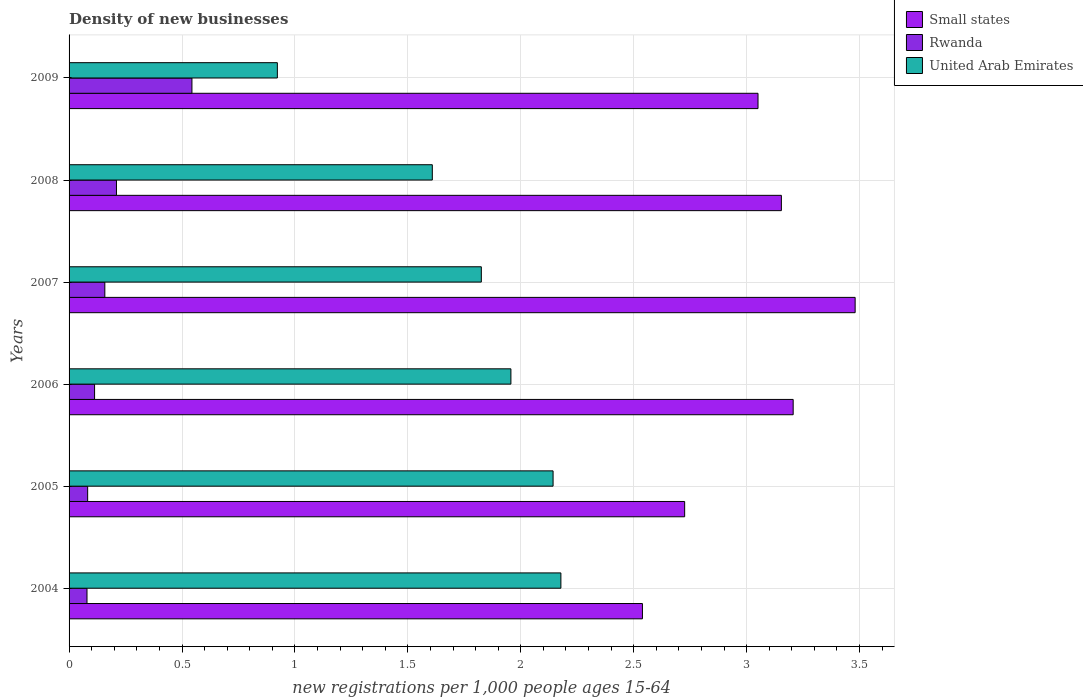Are the number of bars per tick equal to the number of legend labels?
Keep it short and to the point. Yes. How many bars are there on the 3rd tick from the bottom?
Your response must be concise. 3. What is the label of the 2nd group of bars from the top?
Give a very brief answer. 2008. In how many cases, is the number of bars for a given year not equal to the number of legend labels?
Provide a short and direct response. 0. What is the number of new registrations in United Arab Emirates in 2006?
Provide a succinct answer. 1.96. Across all years, what is the maximum number of new registrations in United Arab Emirates?
Your response must be concise. 2.18. Across all years, what is the minimum number of new registrations in Rwanda?
Ensure brevity in your answer.  0.08. In which year was the number of new registrations in United Arab Emirates maximum?
Offer a terse response. 2004. In which year was the number of new registrations in United Arab Emirates minimum?
Provide a succinct answer. 2009. What is the total number of new registrations in Rwanda in the graph?
Your answer should be very brief. 1.19. What is the difference between the number of new registrations in Small states in 2004 and that in 2005?
Provide a succinct answer. -0.19. What is the difference between the number of new registrations in Rwanda in 2004 and the number of new registrations in United Arab Emirates in 2009?
Give a very brief answer. -0.84. What is the average number of new registrations in Small states per year?
Make the answer very short. 3.03. In the year 2009, what is the difference between the number of new registrations in Small states and number of new registrations in Rwanda?
Offer a very short reply. 2.51. What is the ratio of the number of new registrations in United Arab Emirates in 2007 to that in 2008?
Keep it short and to the point. 1.13. Is the difference between the number of new registrations in Small states in 2004 and 2007 greater than the difference between the number of new registrations in Rwanda in 2004 and 2007?
Offer a terse response. No. What is the difference between the highest and the second highest number of new registrations in United Arab Emirates?
Make the answer very short. 0.03. What is the difference between the highest and the lowest number of new registrations in Small states?
Your answer should be compact. 0.94. In how many years, is the number of new registrations in Small states greater than the average number of new registrations in Small states taken over all years?
Make the answer very short. 4. Is the sum of the number of new registrations in United Arab Emirates in 2004 and 2005 greater than the maximum number of new registrations in Small states across all years?
Provide a short and direct response. Yes. What does the 1st bar from the top in 2007 represents?
Make the answer very short. United Arab Emirates. What does the 2nd bar from the bottom in 2009 represents?
Provide a short and direct response. Rwanda. Is it the case that in every year, the sum of the number of new registrations in Rwanda and number of new registrations in Small states is greater than the number of new registrations in United Arab Emirates?
Keep it short and to the point. Yes. Are all the bars in the graph horizontal?
Provide a short and direct response. Yes. How many years are there in the graph?
Make the answer very short. 6. Are the values on the major ticks of X-axis written in scientific E-notation?
Ensure brevity in your answer.  No. What is the title of the graph?
Offer a very short reply. Density of new businesses. Does "Puerto Rico" appear as one of the legend labels in the graph?
Keep it short and to the point. No. What is the label or title of the X-axis?
Your response must be concise. New registrations per 1,0 people ages 15-64. What is the label or title of the Y-axis?
Your response must be concise. Years. What is the new registrations per 1,000 people ages 15-64 in Small states in 2004?
Provide a short and direct response. 2.54. What is the new registrations per 1,000 people ages 15-64 in Rwanda in 2004?
Your answer should be very brief. 0.08. What is the new registrations per 1,000 people ages 15-64 in United Arab Emirates in 2004?
Your response must be concise. 2.18. What is the new registrations per 1,000 people ages 15-64 in Small states in 2005?
Provide a succinct answer. 2.73. What is the new registrations per 1,000 people ages 15-64 of Rwanda in 2005?
Provide a short and direct response. 0.08. What is the new registrations per 1,000 people ages 15-64 of United Arab Emirates in 2005?
Give a very brief answer. 2.14. What is the new registrations per 1,000 people ages 15-64 in Small states in 2006?
Make the answer very short. 3.21. What is the new registrations per 1,000 people ages 15-64 of Rwanda in 2006?
Provide a succinct answer. 0.11. What is the new registrations per 1,000 people ages 15-64 of United Arab Emirates in 2006?
Provide a succinct answer. 1.96. What is the new registrations per 1,000 people ages 15-64 in Small states in 2007?
Offer a very short reply. 3.48. What is the new registrations per 1,000 people ages 15-64 in Rwanda in 2007?
Your answer should be compact. 0.16. What is the new registrations per 1,000 people ages 15-64 of United Arab Emirates in 2007?
Provide a short and direct response. 1.83. What is the new registrations per 1,000 people ages 15-64 in Small states in 2008?
Provide a short and direct response. 3.15. What is the new registrations per 1,000 people ages 15-64 in Rwanda in 2008?
Offer a very short reply. 0.21. What is the new registrations per 1,000 people ages 15-64 of United Arab Emirates in 2008?
Your answer should be compact. 1.61. What is the new registrations per 1,000 people ages 15-64 of Small states in 2009?
Your answer should be very brief. 3.05. What is the new registrations per 1,000 people ages 15-64 in Rwanda in 2009?
Provide a short and direct response. 0.54. What is the new registrations per 1,000 people ages 15-64 in United Arab Emirates in 2009?
Your answer should be compact. 0.92. Across all years, what is the maximum new registrations per 1,000 people ages 15-64 in Small states?
Provide a succinct answer. 3.48. Across all years, what is the maximum new registrations per 1,000 people ages 15-64 in Rwanda?
Offer a very short reply. 0.54. Across all years, what is the maximum new registrations per 1,000 people ages 15-64 in United Arab Emirates?
Make the answer very short. 2.18. Across all years, what is the minimum new registrations per 1,000 people ages 15-64 of Small states?
Your answer should be compact. 2.54. Across all years, what is the minimum new registrations per 1,000 people ages 15-64 in Rwanda?
Ensure brevity in your answer.  0.08. Across all years, what is the minimum new registrations per 1,000 people ages 15-64 of United Arab Emirates?
Keep it short and to the point. 0.92. What is the total new registrations per 1,000 people ages 15-64 of Small states in the graph?
Give a very brief answer. 18.16. What is the total new registrations per 1,000 people ages 15-64 in Rwanda in the graph?
Your answer should be compact. 1.19. What is the total new registrations per 1,000 people ages 15-64 in United Arab Emirates in the graph?
Offer a very short reply. 10.63. What is the difference between the new registrations per 1,000 people ages 15-64 in Small states in 2004 and that in 2005?
Your answer should be compact. -0.19. What is the difference between the new registrations per 1,000 people ages 15-64 of Rwanda in 2004 and that in 2005?
Ensure brevity in your answer.  -0. What is the difference between the new registrations per 1,000 people ages 15-64 in United Arab Emirates in 2004 and that in 2005?
Keep it short and to the point. 0.03. What is the difference between the new registrations per 1,000 people ages 15-64 in Small states in 2004 and that in 2006?
Keep it short and to the point. -0.67. What is the difference between the new registrations per 1,000 people ages 15-64 in Rwanda in 2004 and that in 2006?
Make the answer very short. -0.03. What is the difference between the new registrations per 1,000 people ages 15-64 of United Arab Emirates in 2004 and that in 2006?
Ensure brevity in your answer.  0.22. What is the difference between the new registrations per 1,000 people ages 15-64 of Small states in 2004 and that in 2007?
Give a very brief answer. -0.94. What is the difference between the new registrations per 1,000 people ages 15-64 of Rwanda in 2004 and that in 2007?
Provide a succinct answer. -0.08. What is the difference between the new registrations per 1,000 people ages 15-64 of United Arab Emirates in 2004 and that in 2007?
Make the answer very short. 0.35. What is the difference between the new registrations per 1,000 people ages 15-64 of Small states in 2004 and that in 2008?
Your response must be concise. -0.62. What is the difference between the new registrations per 1,000 people ages 15-64 in Rwanda in 2004 and that in 2008?
Keep it short and to the point. -0.13. What is the difference between the new registrations per 1,000 people ages 15-64 in United Arab Emirates in 2004 and that in 2008?
Your answer should be very brief. 0.57. What is the difference between the new registrations per 1,000 people ages 15-64 in Small states in 2004 and that in 2009?
Your response must be concise. -0.51. What is the difference between the new registrations per 1,000 people ages 15-64 of Rwanda in 2004 and that in 2009?
Your answer should be compact. -0.46. What is the difference between the new registrations per 1,000 people ages 15-64 in United Arab Emirates in 2004 and that in 2009?
Provide a short and direct response. 1.26. What is the difference between the new registrations per 1,000 people ages 15-64 in Small states in 2005 and that in 2006?
Ensure brevity in your answer.  -0.48. What is the difference between the new registrations per 1,000 people ages 15-64 of Rwanda in 2005 and that in 2006?
Give a very brief answer. -0.03. What is the difference between the new registrations per 1,000 people ages 15-64 of United Arab Emirates in 2005 and that in 2006?
Your answer should be very brief. 0.19. What is the difference between the new registrations per 1,000 people ages 15-64 in Small states in 2005 and that in 2007?
Give a very brief answer. -0.75. What is the difference between the new registrations per 1,000 people ages 15-64 of Rwanda in 2005 and that in 2007?
Offer a terse response. -0.08. What is the difference between the new registrations per 1,000 people ages 15-64 in United Arab Emirates in 2005 and that in 2007?
Ensure brevity in your answer.  0.32. What is the difference between the new registrations per 1,000 people ages 15-64 in Small states in 2005 and that in 2008?
Keep it short and to the point. -0.43. What is the difference between the new registrations per 1,000 people ages 15-64 of Rwanda in 2005 and that in 2008?
Make the answer very short. -0.13. What is the difference between the new registrations per 1,000 people ages 15-64 in United Arab Emirates in 2005 and that in 2008?
Ensure brevity in your answer.  0.53. What is the difference between the new registrations per 1,000 people ages 15-64 of Small states in 2005 and that in 2009?
Provide a succinct answer. -0.32. What is the difference between the new registrations per 1,000 people ages 15-64 in Rwanda in 2005 and that in 2009?
Keep it short and to the point. -0.46. What is the difference between the new registrations per 1,000 people ages 15-64 in United Arab Emirates in 2005 and that in 2009?
Keep it short and to the point. 1.22. What is the difference between the new registrations per 1,000 people ages 15-64 of Small states in 2006 and that in 2007?
Ensure brevity in your answer.  -0.27. What is the difference between the new registrations per 1,000 people ages 15-64 in Rwanda in 2006 and that in 2007?
Offer a very short reply. -0.05. What is the difference between the new registrations per 1,000 people ages 15-64 in United Arab Emirates in 2006 and that in 2007?
Ensure brevity in your answer.  0.13. What is the difference between the new registrations per 1,000 people ages 15-64 of Small states in 2006 and that in 2008?
Your response must be concise. 0.05. What is the difference between the new registrations per 1,000 people ages 15-64 in Rwanda in 2006 and that in 2008?
Your answer should be very brief. -0.1. What is the difference between the new registrations per 1,000 people ages 15-64 in United Arab Emirates in 2006 and that in 2008?
Offer a terse response. 0.35. What is the difference between the new registrations per 1,000 people ages 15-64 of Small states in 2006 and that in 2009?
Offer a terse response. 0.16. What is the difference between the new registrations per 1,000 people ages 15-64 in Rwanda in 2006 and that in 2009?
Make the answer very short. -0.43. What is the difference between the new registrations per 1,000 people ages 15-64 in United Arab Emirates in 2006 and that in 2009?
Make the answer very short. 1.03. What is the difference between the new registrations per 1,000 people ages 15-64 in Small states in 2007 and that in 2008?
Your response must be concise. 0.33. What is the difference between the new registrations per 1,000 people ages 15-64 of Rwanda in 2007 and that in 2008?
Offer a terse response. -0.05. What is the difference between the new registrations per 1,000 people ages 15-64 of United Arab Emirates in 2007 and that in 2008?
Offer a terse response. 0.22. What is the difference between the new registrations per 1,000 people ages 15-64 of Small states in 2007 and that in 2009?
Your answer should be very brief. 0.43. What is the difference between the new registrations per 1,000 people ages 15-64 in Rwanda in 2007 and that in 2009?
Offer a terse response. -0.39. What is the difference between the new registrations per 1,000 people ages 15-64 of United Arab Emirates in 2007 and that in 2009?
Ensure brevity in your answer.  0.9. What is the difference between the new registrations per 1,000 people ages 15-64 in Small states in 2008 and that in 2009?
Your answer should be compact. 0.1. What is the difference between the new registrations per 1,000 people ages 15-64 of Rwanda in 2008 and that in 2009?
Provide a short and direct response. -0.33. What is the difference between the new registrations per 1,000 people ages 15-64 in United Arab Emirates in 2008 and that in 2009?
Give a very brief answer. 0.69. What is the difference between the new registrations per 1,000 people ages 15-64 of Small states in 2004 and the new registrations per 1,000 people ages 15-64 of Rwanda in 2005?
Offer a terse response. 2.46. What is the difference between the new registrations per 1,000 people ages 15-64 in Small states in 2004 and the new registrations per 1,000 people ages 15-64 in United Arab Emirates in 2005?
Your answer should be compact. 0.4. What is the difference between the new registrations per 1,000 people ages 15-64 in Rwanda in 2004 and the new registrations per 1,000 people ages 15-64 in United Arab Emirates in 2005?
Give a very brief answer. -2.06. What is the difference between the new registrations per 1,000 people ages 15-64 in Small states in 2004 and the new registrations per 1,000 people ages 15-64 in Rwanda in 2006?
Offer a terse response. 2.43. What is the difference between the new registrations per 1,000 people ages 15-64 of Small states in 2004 and the new registrations per 1,000 people ages 15-64 of United Arab Emirates in 2006?
Make the answer very short. 0.58. What is the difference between the new registrations per 1,000 people ages 15-64 of Rwanda in 2004 and the new registrations per 1,000 people ages 15-64 of United Arab Emirates in 2006?
Keep it short and to the point. -1.88. What is the difference between the new registrations per 1,000 people ages 15-64 of Small states in 2004 and the new registrations per 1,000 people ages 15-64 of Rwanda in 2007?
Make the answer very short. 2.38. What is the difference between the new registrations per 1,000 people ages 15-64 in Small states in 2004 and the new registrations per 1,000 people ages 15-64 in United Arab Emirates in 2007?
Offer a terse response. 0.71. What is the difference between the new registrations per 1,000 people ages 15-64 in Rwanda in 2004 and the new registrations per 1,000 people ages 15-64 in United Arab Emirates in 2007?
Provide a short and direct response. -1.75. What is the difference between the new registrations per 1,000 people ages 15-64 in Small states in 2004 and the new registrations per 1,000 people ages 15-64 in Rwanda in 2008?
Offer a very short reply. 2.33. What is the difference between the new registrations per 1,000 people ages 15-64 of Small states in 2004 and the new registrations per 1,000 people ages 15-64 of United Arab Emirates in 2008?
Make the answer very short. 0.93. What is the difference between the new registrations per 1,000 people ages 15-64 of Rwanda in 2004 and the new registrations per 1,000 people ages 15-64 of United Arab Emirates in 2008?
Provide a succinct answer. -1.53. What is the difference between the new registrations per 1,000 people ages 15-64 of Small states in 2004 and the new registrations per 1,000 people ages 15-64 of Rwanda in 2009?
Give a very brief answer. 1.99. What is the difference between the new registrations per 1,000 people ages 15-64 of Small states in 2004 and the new registrations per 1,000 people ages 15-64 of United Arab Emirates in 2009?
Provide a succinct answer. 1.62. What is the difference between the new registrations per 1,000 people ages 15-64 of Rwanda in 2004 and the new registrations per 1,000 people ages 15-64 of United Arab Emirates in 2009?
Offer a very short reply. -0.84. What is the difference between the new registrations per 1,000 people ages 15-64 in Small states in 2005 and the new registrations per 1,000 people ages 15-64 in Rwanda in 2006?
Ensure brevity in your answer.  2.61. What is the difference between the new registrations per 1,000 people ages 15-64 in Small states in 2005 and the new registrations per 1,000 people ages 15-64 in United Arab Emirates in 2006?
Ensure brevity in your answer.  0.77. What is the difference between the new registrations per 1,000 people ages 15-64 of Rwanda in 2005 and the new registrations per 1,000 people ages 15-64 of United Arab Emirates in 2006?
Your answer should be very brief. -1.87. What is the difference between the new registrations per 1,000 people ages 15-64 of Small states in 2005 and the new registrations per 1,000 people ages 15-64 of Rwanda in 2007?
Provide a succinct answer. 2.57. What is the difference between the new registrations per 1,000 people ages 15-64 of Small states in 2005 and the new registrations per 1,000 people ages 15-64 of United Arab Emirates in 2007?
Ensure brevity in your answer.  0.9. What is the difference between the new registrations per 1,000 people ages 15-64 of Rwanda in 2005 and the new registrations per 1,000 people ages 15-64 of United Arab Emirates in 2007?
Keep it short and to the point. -1.74. What is the difference between the new registrations per 1,000 people ages 15-64 of Small states in 2005 and the new registrations per 1,000 people ages 15-64 of Rwanda in 2008?
Provide a succinct answer. 2.52. What is the difference between the new registrations per 1,000 people ages 15-64 of Small states in 2005 and the new registrations per 1,000 people ages 15-64 of United Arab Emirates in 2008?
Provide a short and direct response. 1.12. What is the difference between the new registrations per 1,000 people ages 15-64 in Rwanda in 2005 and the new registrations per 1,000 people ages 15-64 in United Arab Emirates in 2008?
Make the answer very short. -1.53. What is the difference between the new registrations per 1,000 people ages 15-64 of Small states in 2005 and the new registrations per 1,000 people ages 15-64 of Rwanda in 2009?
Make the answer very short. 2.18. What is the difference between the new registrations per 1,000 people ages 15-64 in Small states in 2005 and the new registrations per 1,000 people ages 15-64 in United Arab Emirates in 2009?
Your answer should be very brief. 1.8. What is the difference between the new registrations per 1,000 people ages 15-64 in Rwanda in 2005 and the new registrations per 1,000 people ages 15-64 in United Arab Emirates in 2009?
Your answer should be very brief. -0.84. What is the difference between the new registrations per 1,000 people ages 15-64 of Small states in 2006 and the new registrations per 1,000 people ages 15-64 of Rwanda in 2007?
Keep it short and to the point. 3.05. What is the difference between the new registrations per 1,000 people ages 15-64 in Small states in 2006 and the new registrations per 1,000 people ages 15-64 in United Arab Emirates in 2007?
Your answer should be compact. 1.38. What is the difference between the new registrations per 1,000 people ages 15-64 in Rwanda in 2006 and the new registrations per 1,000 people ages 15-64 in United Arab Emirates in 2007?
Provide a succinct answer. -1.71. What is the difference between the new registrations per 1,000 people ages 15-64 in Small states in 2006 and the new registrations per 1,000 people ages 15-64 in Rwanda in 2008?
Your answer should be very brief. 3. What is the difference between the new registrations per 1,000 people ages 15-64 in Small states in 2006 and the new registrations per 1,000 people ages 15-64 in United Arab Emirates in 2008?
Your answer should be very brief. 1.6. What is the difference between the new registrations per 1,000 people ages 15-64 of Rwanda in 2006 and the new registrations per 1,000 people ages 15-64 of United Arab Emirates in 2008?
Keep it short and to the point. -1.5. What is the difference between the new registrations per 1,000 people ages 15-64 of Small states in 2006 and the new registrations per 1,000 people ages 15-64 of Rwanda in 2009?
Your response must be concise. 2.66. What is the difference between the new registrations per 1,000 people ages 15-64 in Small states in 2006 and the new registrations per 1,000 people ages 15-64 in United Arab Emirates in 2009?
Make the answer very short. 2.28. What is the difference between the new registrations per 1,000 people ages 15-64 of Rwanda in 2006 and the new registrations per 1,000 people ages 15-64 of United Arab Emirates in 2009?
Give a very brief answer. -0.81. What is the difference between the new registrations per 1,000 people ages 15-64 in Small states in 2007 and the new registrations per 1,000 people ages 15-64 in Rwanda in 2008?
Offer a very short reply. 3.27. What is the difference between the new registrations per 1,000 people ages 15-64 of Small states in 2007 and the new registrations per 1,000 people ages 15-64 of United Arab Emirates in 2008?
Give a very brief answer. 1.87. What is the difference between the new registrations per 1,000 people ages 15-64 of Rwanda in 2007 and the new registrations per 1,000 people ages 15-64 of United Arab Emirates in 2008?
Your response must be concise. -1.45. What is the difference between the new registrations per 1,000 people ages 15-64 of Small states in 2007 and the new registrations per 1,000 people ages 15-64 of Rwanda in 2009?
Offer a very short reply. 2.94. What is the difference between the new registrations per 1,000 people ages 15-64 of Small states in 2007 and the new registrations per 1,000 people ages 15-64 of United Arab Emirates in 2009?
Offer a terse response. 2.56. What is the difference between the new registrations per 1,000 people ages 15-64 of Rwanda in 2007 and the new registrations per 1,000 people ages 15-64 of United Arab Emirates in 2009?
Offer a very short reply. -0.76. What is the difference between the new registrations per 1,000 people ages 15-64 in Small states in 2008 and the new registrations per 1,000 people ages 15-64 in Rwanda in 2009?
Your answer should be compact. 2.61. What is the difference between the new registrations per 1,000 people ages 15-64 in Small states in 2008 and the new registrations per 1,000 people ages 15-64 in United Arab Emirates in 2009?
Ensure brevity in your answer.  2.23. What is the difference between the new registrations per 1,000 people ages 15-64 of Rwanda in 2008 and the new registrations per 1,000 people ages 15-64 of United Arab Emirates in 2009?
Ensure brevity in your answer.  -0.71. What is the average new registrations per 1,000 people ages 15-64 of Small states per year?
Give a very brief answer. 3.03. What is the average new registrations per 1,000 people ages 15-64 in Rwanda per year?
Provide a succinct answer. 0.2. What is the average new registrations per 1,000 people ages 15-64 of United Arab Emirates per year?
Your answer should be very brief. 1.77. In the year 2004, what is the difference between the new registrations per 1,000 people ages 15-64 in Small states and new registrations per 1,000 people ages 15-64 in Rwanda?
Offer a very short reply. 2.46. In the year 2004, what is the difference between the new registrations per 1,000 people ages 15-64 of Small states and new registrations per 1,000 people ages 15-64 of United Arab Emirates?
Offer a very short reply. 0.36. In the year 2004, what is the difference between the new registrations per 1,000 people ages 15-64 of Rwanda and new registrations per 1,000 people ages 15-64 of United Arab Emirates?
Keep it short and to the point. -2.1. In the year 2005, what is the difference between the new registrations per 1,000 people ages 15-64 in Small states and new registrations per 1,000 people ages 15-64 in Rwanda?
Give a very brief answer. 2.64. In the year 2005, what is the difference between the new registrations per 1,000 people ages 15-64 in Small states and new registrations per 1,000 people ages 15-64 in United Arab Emirates?
Offer a very short reply. 0.58. In the year 2005, what is the difference between the new registrations per 1,000 people ages 15-64 of Rwanda and new registrations per 1,000 people ages 15-64 of United Arab Emirates?
Make the answer very short. -2.06. In the year 2006, what is the difference between the new registrations per 1,000 people ages 15-64 in Small states and new registrations per 1,000 people ages 15-64 in Rwanda?
Offer a very short reply. 3.09. In the year 2006, what is the difference between the new registrations per 1,000 people ages 15-64 of Small states and new registrations per 1,000 people ages 15-64 of United Arab Emirates?
Make the answer very short. 1.25. In the year 2006, what is the difference between the new registrations per 1,000 people ages 15-64 in Rwanda and new registrations per 1,000 people ages 15-64 in United Arab Emirates?
Provide a short and direct response. -1.84. In the year 2007, what is the difference between the new registrations per 1,000 people ages 15-64 in Small states and new registrations per 1,000 people ages 15-64 in Rwanda?
Ensure brevity in your answer.  3.32. In the year 2007, what is the difference between the new registrations per 1,000 people ages 15-64 in Small states and new registrations per 1,000 people ages 15-64 in United Arab Emirates?
Provide a succinct answer. 1.66. In the year 2007, what is the difference between the new registrations per 1,000 people ages 15-64 of Rwanda and new registrations per 1,000 people ages 15-64 of United Arab Emirates?
Offer a very short reply. -1.67. In the year 2008, what is the difference between the new registrations per 1,000 people ages 15-64 in Small states and new registrations per 1,000 people ages 15-64 in Rwanda?
Your response must be concise. 2.94. In the year 2008, what is the difference between the new registrations per 1,000 people ages 15-64 of Small states and new registrations per 1,000 people ages 15-64 of United Arab Emirates?
Your response must be concise. 1.55. In the year 2008, what is the difference between the new registrations per 1,000 people ages 15-64 of Rwanda and new registrations per 1,000 people ages 15-64 of United Arab Emirates?
Ensure brevity in your answer.  -1.4. In the year 2009, what is the difference between the new registrations per 1,000 people ages 15-64 of Small states and new registrations per 1,000 people ages 15-64 of Rwanda?
Give a very brief answer. 2.51. In the year 2009, what is the difference between the new registrations per 1,000 people ages 15-64 of Small states and new registrations per 1,000 people ages 15-64 of United Arab Emirates?
Provide a succinct answer. 2.13. In the year 2009, what is the difference between the new registrations per 1,000 people ages 15-64 in Rwanda and new registrations per 1,000 people ages 15-64 in United Arab Emirates?
Provide a succinct answer. -0.38. What is the ratio of the new registrations per 1,000 people ages 15-64 of Small states in 2004 to that in 2005?
Your answer should be compact. 0.93. What is the ratio of the new registrations per 1,000 people ages 15-64 of Rwanda in 2004 to that in 2005?
Provide a short and direct response. 0.97. What is the ratio of the new registrations per 1,000 people ages 15-64 of United Arab Emirates in 2004 to that in 2005?
Offer a very short reply. 1.02. What is the ratio of the new registrations per 1,000 people ages 15-64 in Small states in 2004 to that in 2006?
Offer a terse response. 0.79. What is the ratio of the new registrations per 1,000 people ages 15-64 in Rwanda in 2004 to that in 2006?
Make the answer very short. 0.7. What is the ratio of the new registrations per 1,000 people ages 15-64 of United Arab Emirates in 2004 to that in 2006?
Ensure brevity in your answer.  1.11. What is the ratio of the new registrations per 1,000 people ages 15-64 in Small states in 2004 to that in 2007?
Ensure brevity in your answer.  0.73. What is the ratio of the new registrations per 1,000 people ages 15-64 in Rwanda in 2004 to that in 2007?
Your answer should be very brief. 0.5. What is the ratio of the new registrations per 1,000 people ages 15-64 of United Arab Emirates in 2004 to that in 2007?
Your answer should be very brief. 1.19. What is the ratio of the new registrations per 1,000 people ages 15-64 in Small states in 2004 to that in 2008?
Give a very brief answer. 0.8. What is the ratio of the new registrations per 1,000 people ages 15-64 of Rwanda in 2004 to that in 2008?
Provide a succinct answer. 0.38. What is the ratio of the new registrations per 1,000 people ages 15-64 in United Arab Emirates in 2004 to that in 2008?
Offer a terse response. 1.35. What is the ratio of the new registrations per 1,000 people ages 15-64 of Small states in 2004 to that in 2009?
Your answer should be very brief. 0.83. What is the ratio of the new registrations per 1,000 people ages 15-64 of Rwanda in 2004 to that in 2009?
Keep it short and to the point. 0.15. What is the ratio of the new registrations per 1,000 people ages 15-64 in United Arab Emirates in 2004 to that in 2009?
Offer a terse response. 2.36. What is the ratio of the new registrations per 1,000 people ages 15-64 in Small states in 2005 to that in 2006?
Your answer should be compact. 0.85. What is the ratio of the new registrations per 1,000 people ages 15-64 of Rwanda in 2005 to that in 2006?
Offer a terse response. 0.73. What is the ratio of the new registrations per 1,000 people ages 15-64 of United Arab Emirates in 2005 to that in 2006?
Offer a very short reply. 1.1. What is the ratio of the new registrations per 1,000 people ages 15-64 in Small states in 2005 to that in 2007?
Keep it short and to the point. 0.78. What is the ratio of the new registrations per 1,000 people ages 15-64 in Rwanda in 2005 to that in 2007?
Offer a very short reply. 0.52. What is the ratio of the new registrations per 1,000 people ages 15-64 in United Arab Emirates in 2005 to that in 2007?
Give a very brief answer. 1.17. What is the ratio of the new registrations per 1,000 people ages 15-64 in Small states in 2005 to that in 2008?
Offer a very short reply. 0.86. What is the ratio of the new registrations per 1,000 people ages 15-64 of Rwanda in 2005 to that in 2008?
Your answer should be very brief. 0.39. What is the ratio of the new registrations per 1,000 people ages 15-64 in United Arab Emirates in 2005 to that in 2008?
Provide a short and direct response. 1.33. What is the ratio of the new registrations per 1,000 people ages 15-64 of Small states in 2005 to that in 2009?
Your answer should be compact. 0.89. What is the ratio of the new registrations per 1,000 people ages 15-64 in Rwanda in 2005 to that in 2009?
Offer a terse response. 0.15. What is the ratio of the new registrations per 1,000 people ages 15-64 in United Arab Emirates in 2005 to that in 2009?
Keep it short and to the point. 2.32. What is the ratio of the new registrations per 1,000 people ages 15-64 of Small states in 2006 to that in 2007?
Keep it short and to the point. 0.92. What is the ratio of the new registrations per 1,000 people ages 15-64 of Rwanda in 2006 to that in 2007?
Make the answer very short. 0.71. What is the ratio of the new registrations per 1,000 people ages 15-64 in United Arab Emirates in 2006 to that in 2007?
Keep it short and to the point. 1.07. What is the ratio of the new registrations per 1,000 people ages 15-64 in Small states in 2006 to that in 2008?
Make the answer very short. 1.02. What is the ratio of the new registrations per 1,000 people ages 15-64 in Rwanda in 2006 to that in 2008?
Provide a short and direct response. 0.54. What is the ratio of the new registrations per 1,000 people ages 15-64 in United Arab Emirates in 2006 to that in 2008?
Your answer should be compact. 1.22. What is the ratio of the new registrations per 1,000 people ages 15-64 in Small states in 2006 to that in 2009?
Your answer should be compact. 1.05. What is the ratio of the new registrations per 1,000 people ages 15-64 in Rwanda in 2006 to that in 2009?
Give a very brief answer. 0.21. What is the ratio of the new registrations per 1,000 people ages 15-64 in United Arab Emirates in 2006 to that in 2009?
Your answer should be very brief. 2.12. What is the ratio of the new registrations per 1,000 people ages 15-64 of Small states in 2007 to that in 2008?
Your answer should be compact. 1.1. What is the ratio of the new registrations per 1,000 people ages 15-64 of Rwanda in 2007 to that in 2008?
Your answer should be compact. 0.75. What is the ratio of the new registrations per 1,000 people ages 15-64 of United Arab Emirates in 2007 to that in 2008?
Your answer should be compact. 1.13. What is the ratio of the new registrations per 1,000 people ages 15-64 of Small states in 2007 to that in 2009?
Keep it short and to the point. 1.14. What is the ratio of the new registrations per 1,000 people ages 15-64 of Rwanda in 2007 to that in 2009?
Give a very brief answer. 0.29. What is the ratio of the new registrations per 1,000 people ages 15-64 in United Arab Emirates in 2007 to that in 2009?
Your answer should be compact. 1.98. What is the ratio of the new registrations per 1,000 people ages 15-64 of Small states in 2008 to that in 2009?
Your response must be concise. 1.03. What is the ratio of the new registrations per 1,000 people ages 15-64 in Rwanda in 2008 to that in 2009?
Your answer should be compact. 0.39. What is the ratio of the new registrations per 1,000 people ages 15-64 of United Arab Emirates in 2008 to that in 2009?
Provide a short and direct response. 1.74. What is the difference between the highest and the second highest new registrations per 1,000 people ages 15-64 of Small states?
Offer a terse response. 0.27. What is the difference between the highest and the second highest new registrations per 1,000 people ages 15-64 of Rwanda?
Provide a succinct answer. 0.33. What is the difference between the highest and the second highest new registrations per 1,000 people ages 15-64 of United Arab Emirates?
Your answer should be compact. 0.03. What is the difference between the highest and the lowest new registrations per 1,000 people ages 15-64 of Small states?
Offer a very short reply. 0.94. What is the difference between the highest and the lowest new registrations per 1,000 people ages 15-64 in Rwanda?
Offer a terse response. 0.46. What is the difference between the highest and the lowest new registrations per 1,000 people ages 15-64 of United Arab Emirates?
Provide a short and direct response. 1.26. 